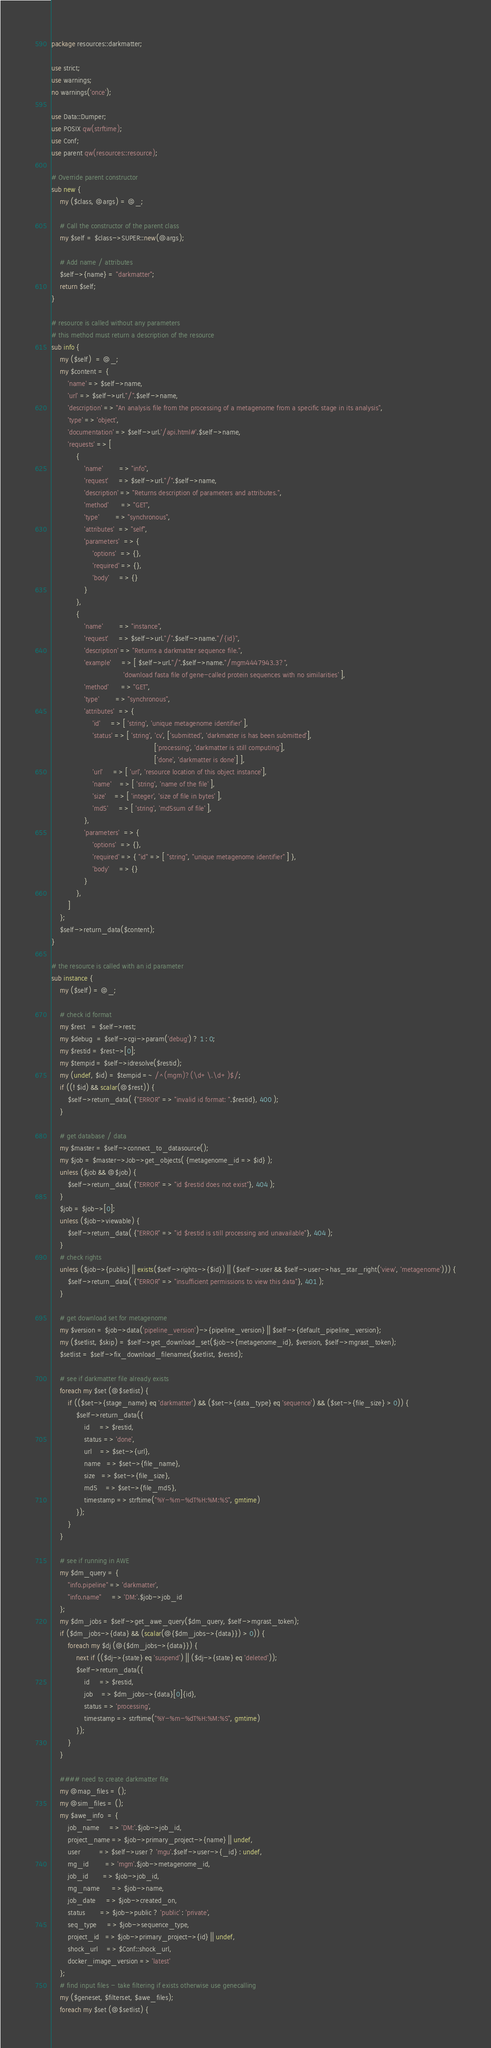<code> <loc_0><loc_0><loc_500><loc_500><_Perl_>package resources::darkmatter;

use strict;
use warnings;
no warnings('once');

use Data::Dumper;
use POSIX qw(strftime);
use Conf;
use parent qw(resources::resource);

# Override parent constructor
sub new {
    my ($class, @args) = @_;

    # Call the constructor of the parent class
    my $self = $class->SUPER::new(@args);
    
    # Add name / attributes
    $self->{name} = "darkmatter";
    return $self;
}

# resource is called without any parameters
# this method must return a description of the resource
sub info {
    my ($self)  = @_;
    my $content = {
        'name' => $self->name,
        'url' => $self->url."/".$self->name,
        'description' => "An analysis file from the processing of a metagenome from a specific stage in its analysis",
        'type' => 'object',
        'documentation' => $self->url.'/api.html#'.$self->name,
        'requests' => [
            {
                'name'        => "info",
                'request'     => $self->url."/".$self->name,
                'description' => "Returns description of parameters and attributes.",
                'method'      => "GET",
                'type'        => "synchronous",
                'attributes'  => "self",
                'parameters'  => {
                    'options'  => {},
                    'required' => {},
                    'body'     => {}
                }
			},
            {
                'name'        => "instance",
                'request'     => $self->url."/".$self->name."/{id}",
                'description' => "Returns a darkmatter sequence file.",
                'example'     => [ $self->url."/".$self->name."/mgm4447943.3?",
      				               'download fasta file of gene-called protein sequences with no similarities' ],
                'method'      => "GET",
                'type'        => "synchronous",
                'attributes'  => {
                    'id'     => [ 'string', 'unique metagenome identifier' ],
                    'status' => [ 'string', 'cv', ['submitted', 'darkmatter is has been submitted'],
                                                  ['processing', 'darkmatter is still computing'],
                                                  ['done', 'darkmatter is done'] ],
                    'url'     => [ 'url', 'resource location of this object instance'],
                    'name'    => [ 'string', 'name of the file' ],
                    'size'    => [ 'integer', 'size of file in bytes' ],
                    'md5'     => [ 'string', 'md5sum of file' ],
                },
                'parameters'  => {
                    'options'  => {},
                    'required' => { "id" => [ "string", "unique metagenome identifier" ] },
                    'body'     => {}
                }
			},
        ]
    };
    $self->return_data($content);
}

# the resource is called with an id parameter
sub instance {
    my ($self) = @_;

    # check id format
    my $rest   = $self->rest;
    my $debug  = $self->cgi->param('debug') ? 1 : 0;
    my $restid = $rest->[0];
    my $tempid = $self->idresolve($restid);
    my (undef, $id) = $tempid =~ /^(mgm)?(\d+\.\d+)$/;
    if ((! $id) && scalar(@$rest)) {
        $self->return_data( {"ERROR" => "invalid id format: ".$restid}, 400 );
    }

    # get database / data
    my $master = $self->connect_to_datasource();
    my $job = $master->Job->get_objects( {metagenome_id => $id} );
    unless ($job && @$job) {
        $self->return_data( {"ERROR" => "id $restid does not exist"}, 404 );
    }
    $job = $job->[0];
    unless ($job->viewable) {
        $self->return_data( {"ERROR" => "id $restid is still processing and unavailable"}, 404 );
    }
    # check rights
    unless ($job->{public} || exists($self->rights->{$id}) || ($self->user && $self->user->has_star_right('view', 'metagenome'))) {
        $self->return_data( {"ERROR" => "insufficient permissions to view this data"}, 401 );
    }
    
    # get download set for metagenome
    my $version = $job->data('pipeline_version')->{pipeline_version} || $self->{default_pipeline_version};
    my ($setlist, $skip) = $self->get_download_set($job->{metagenome_id}, $version, $self->mgrast_token);
    $setlist = $self->fix_download_filenames($setlist, $restid);
    
    # see if darkmatter file already exists
    foreach my $set (@$setlist) {
        if (($set->{stage_name} eq 'darkmatter') && ($set->{data_type} eq 'sequence') && ($set->{file_size} > 0)) {
            $self->return_data({
                id     => $restid,
                status => 'done',
                url    => $set->{url},
                name   => $set->{file_name},
                size   => $set->{file_size},
                md5    => $set->{file_md5},
                timestamp => strftime("%Y-%m-%dT%H:%M:%S", gmtime)
            });
        }
    }
    
    # see if running in AWE
    my $dm_query = {
        "info.pipeline" => 'darkmatter',
        "info.name"     => 'DM:'.$job->job_id
    };
    my $dm_jobs = $self->get_awe_query($dm_query, $self->mgrast_token);
    if ($dm_jobs->{data} && (scalar(@{$dm_jobs->{data}}) > 0)) {
        foreach my $dj (@{$dm_jobs->{data}}) {
            next if (($dj->{state} eq 'suspend') || ($dj->{state} eq 'deleted'));
            $self->return_data({
                id     => $restid,
                job    => $dm_jobs->{data}[0]{id},
                status => 'processing',
                timestamp => strftime("%Y-%m-%dT%H:%M:%S", gmtime)
            });
        }
    }
    
    #### need to create darkmatter file
    my @map_files = ();
    my @sim_files = ();
    my $awe_info  = {
        job_name     => 'DM:'.$job->job_id,
        project_name => $job->primary_project->{name} || undef,
        user         => $self->user ? 'mgu'.$self->user->{_id} : undef,
        mg_id        => 'mgm'.$job->metagenome_id,
        job_id       => $job->job_id,
        mg_name      => $job->name,
        job_date     => $job->created_on,
        status       => $job->public ? 'public' : 'private',
        seq_type     => $job->sequence_type,
        project_id   => $job->primary_project->{id} || undef,
        shock_url    => $Conf::shock_url,
        docker_image_version => 'latest'
    };
    # find input files - take filtering if exists otherwise use genecalling
    my ($geneset, $filterset, $awe_files);
    foreach my $set (@$setlist) {</code> 